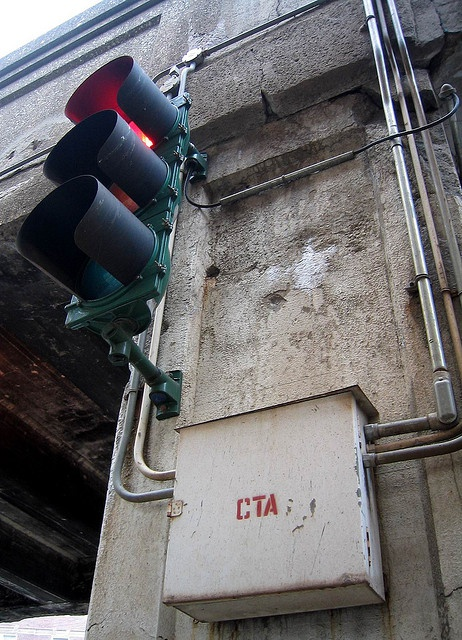Describe the objects in this image and their specific colors. I can see a traffic light in white, black, gray, blue, and navy tones in this image. 